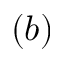<formula> <loc_0><loc_0><loc_500><loc_500>( b )</formula> 